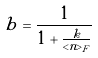Convert formula to latex. <formula><loc_0><loc_0><loc_500><loc_500>b = \frac { 1 } { 1 + \frac { k } { < n > _ { F } } }</formula> 